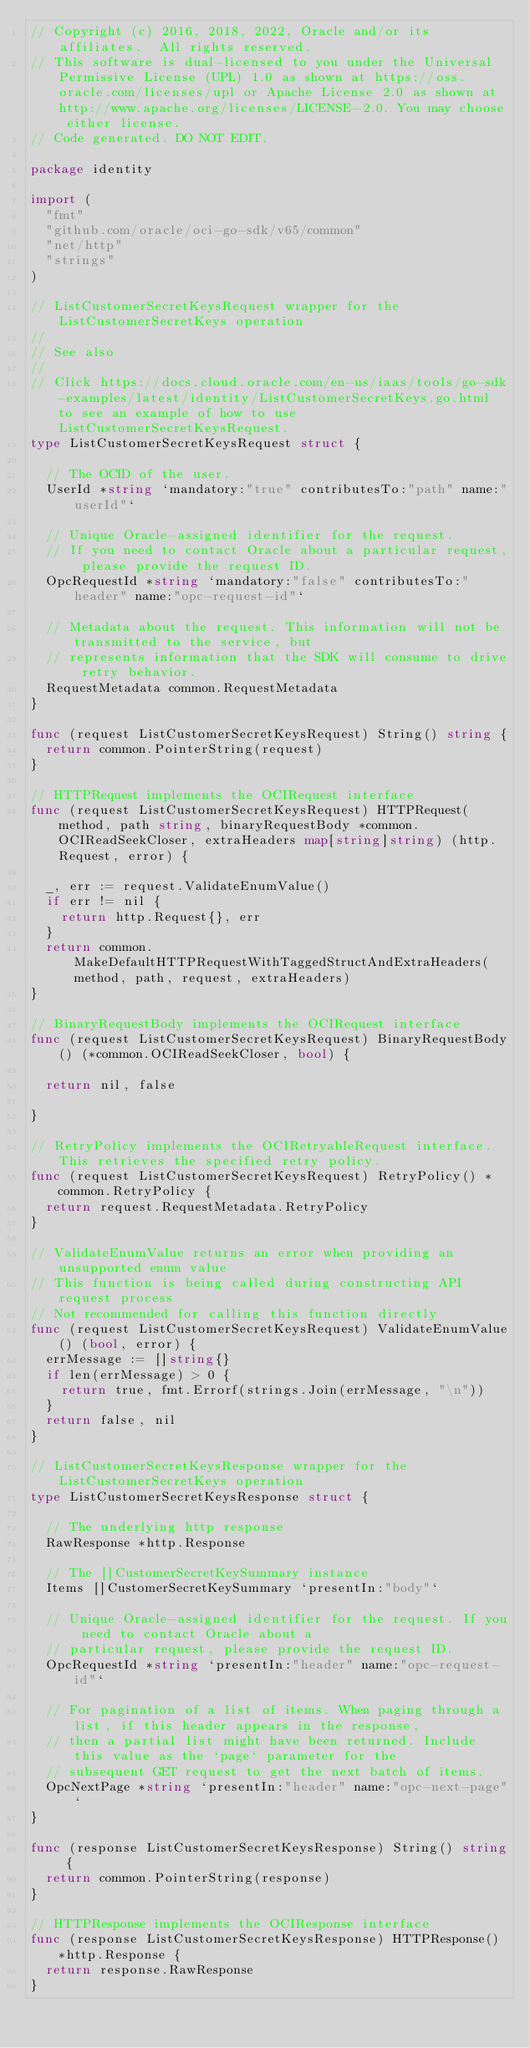<code> <loc_0><loc_0><loc_500><loc_500><_Go_>// Copyright (c) 2016, 2018, 2022, Oracle and/or its affiliates.  All rights reserved.
// This software is dual-licensed to you under the Universal Permissive License (UPL) 1.0 as shown at https://oss.oracle.com/licenses/upl or Apache License 2.0 as shown at http://www.apache.org/licenses/LICENSE-2.0. You may choose either license.
// Code generated. DO NOT EDIT.

package identity

import (
	"fmt"
	"github.com/oracle/oci-go-sdk/v65/common"
	"net/http"
	"strings"
)

// ListCustomerSecretKeysRequest wrapper for the ListCustomerSecretKeys operation
//
// See also
//
// Click https://docs.cloud.oracle.com/en-us/iaas/tools/go-sdk-examples/latest/identity/ListCustomerSecretKeys.go.html to see an example of how to use ListCustomerSecretKeysRequest.
type ListCustomerSecretKeysRequest struct {

	// The OCID of the user.
	UserId *string `mandatory:"true" contributesTo:"path" name:"userId"`

	// Unique Oracle-assigned identifier for the request.
	// If you need to contact Oracle about a particular request, please provide the request ID.
	OpcRequestId *string `mandatory:"false" contributesTo:"header" name:"opc-request-id"`

	// Metadata about the request. This information will not be transmitted to the service, but
	// represents information that the SDK will consume to drive retry behavior.
	RequestMetadata common.RequestMetadata
}

func (request ListCustomerSecretKeysRequest) String() string {
	return common.PointerString(request)
}

// HTTPRequest implements the OCIRequest interface
func (request ListCustomerSecretKeysRequest) HTTPRequest(method, path string, binaryRequestBody *common.OCIReadSeekCloser, extraHeaders map[string]string) (http.Request, error) {

	_, err := request.ValidateEnumValue()
	if err != nil {
		return http.Request{}, err
	}
	return common.MakeDefaultHTTPRequestWithTaggedStructAndExtraHeaders(method, path, request, extraHeaders)
}

// BinaryRequestBody implements the OCIRequest interface
func (request ListCustomerSecretKeysRequest) BinaryRequestBody() (*common.OCIReadSeekCloser, bool) {

	return nil, false

}

// RetryPolicy implements the OCIRetryableRequest interface. This retrieves the specified retry policy.
func (request ListCustomerSecretKeysRequest) RetryPolicy() *common.RetryPolicy {
	return request.RequestMetadata.RetryPolicy
}

// ValidateEnumValue returns an error when providing an unsupported enum value
// This function is being called during constructing API request process
// Not recommended for calling this function directly
func (request ListCustomerSecretKeysRequest) ValidateEnumValue() (bool, error) {
	errMessage := []string{}
	if len(errMessage) > 0 {
		return true, fmt.Errorf(strings.Join(errMessage, "\n"))
	}
	return false, nil
}

// ListCustomerSecretKeysResponse wrapper for the ListCustomerSecretKeys operation
type ListCustomerSecretKeysResponse struct {

	// The underlying http response
	RawResponse *http.Response

	// The []CustomerSecretKeySummary instance
	Items []CustomerSecretKeySummary `presentIn:"body"`

	// Unique Oracle-assigned identifier for the request. If you need to contact Oracle about a
	// particular request, please provide the request ID.
	OpcRequestId *string `presentIn:"header" name:"opc-request-id"`

	// For pagination of a list of items. When paging through a list, if this header appears in the response,
	// then a partial list might have been returned. Include this value as the `page` parameter for the
	// subsequent GET request to get the next batch of items.
	OpcNextPage *string `presentIn:"header" name:"opc-next-page"`
}

func (response ListCustomerSecretKeysResponse) String() string {
	return common.PointerString(response)
}

// HTTPResponse implements the OCIResponse interface
func (response ListCustomerSecretKeysResponse) HTTPResponse() *http.Response {
	return response.RawResponse
}
</code> 